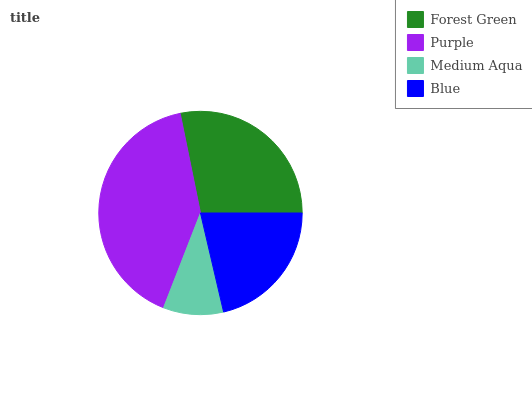Is Medium Aqua the minimum?
Answer yes or no. Yes. Is Purple the maximum?
Answer yes or no. Yes. Is Purple the minimum?
Answer yes or no. No. Is Medium Aqua the maximum?
Answer yes or no. No. Is Purple greater than Medium Aqua?
Answer yes or no. Yes. Is Medium Aqua less than Purple?
Answer yes or no. Yes. Is Medium Aqua greater than Purple?
Answer yes or no. No. Is Purple less than Medium Aqua?
Answer yes or no. No. Is Forest Green the high median?
Answer yes or no. Yes. Is Blue the low median?
Answer yes or no. Yes. Is Medium Aqua the high median?
Answer yes or no. No. Is Forest Green the low median?
Answer yes or no. No. 